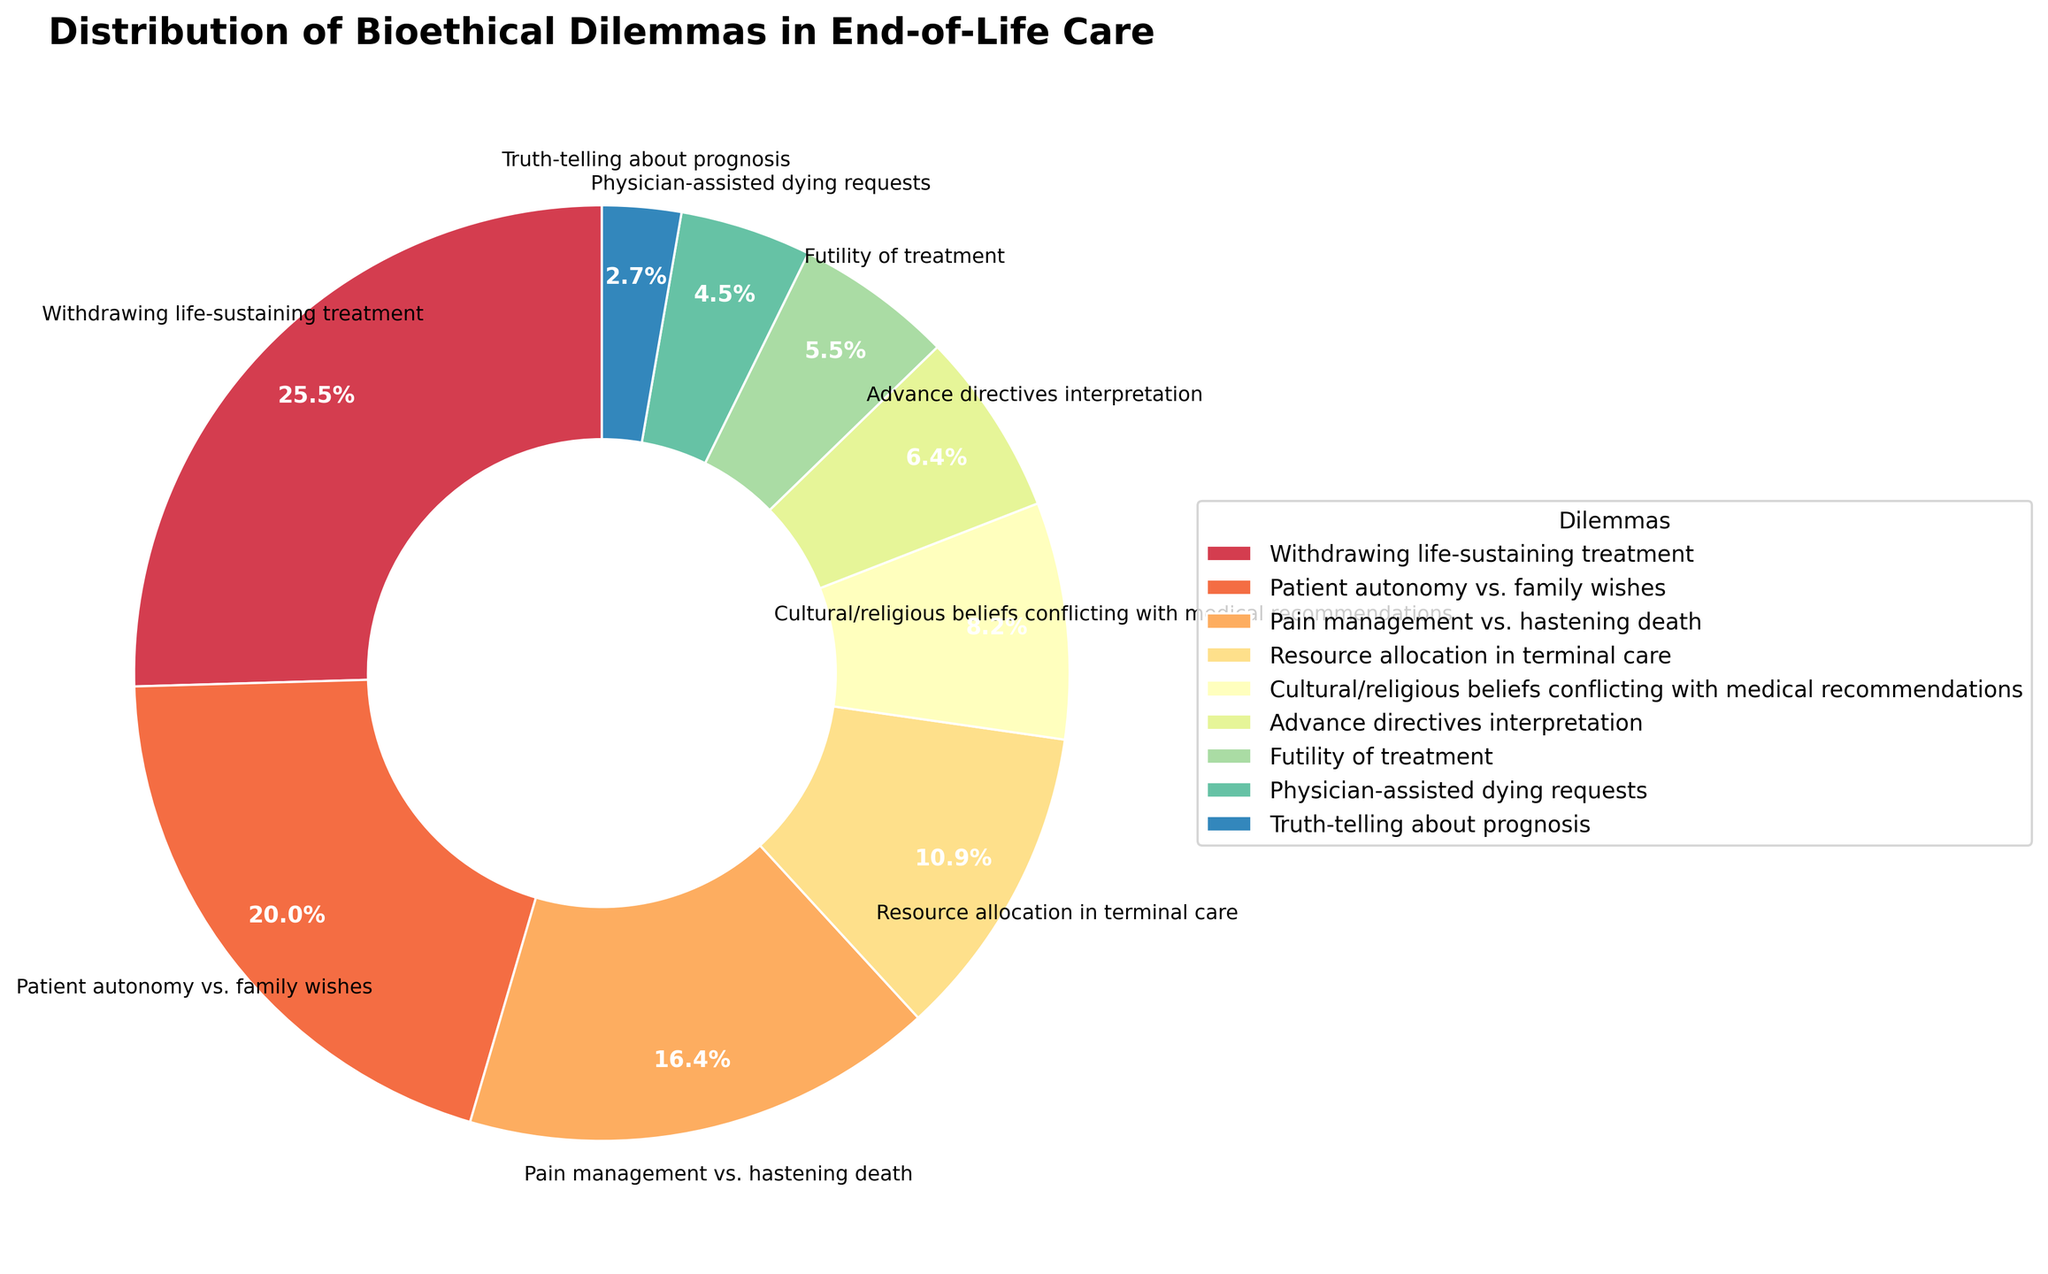What percentage of dilemmas are related to "Withdrawing life-sustaining treatment"? Look at the figure and find the wedge labeled "Withdrawing life-sustaining treatment." The percentage value is displayed within the wedge.
Answer: 28% Which ethical dilemma is represented by the smallest percentage? Examine the wedges in the pie chart and find the one with the smallest percentage value. The label associated with this wedge identifies the dilemma.
Answer: Truth-telling about prognosis What is the total percentage of dilemmas related to "Patient autonomy vs. family wishes" and "Pain management vs. hastening death"? Locate the wedges for "Patient autonomy vs. family wishes" and "Pain management vs. hastening death." Add their percentages, which are given in the figure.
Answer: 22 + 18 = 40% Which dilemma has a higher percentage: "Resource allocation in terminal care" or "Advance directives interpretation"? Compare the two respective wedges in the pie chart for "Resource allocation in terminal care" and "Advance directives interpretation" to determine which has a higher percentage.
Answer: Resource allocation in terminal care How does the percentage of "Cultural/religious beliefs conflicting with medical recommendations" compare to the percentage of "Physician-assisted dying requests"? Which is greater and by how much? Find the wedges for "Cultural/religious beliefs conflicting with medical recommendations" and "Physician-assisted dying requests." Subtract the smaller percentage from the larger to find the difference.
Answer: 9% - 5% = 4% What is the combined percentage of dilemmas related to "Futility of treatment" and "Truth-telling about prognosis"? Locate "Futility of treatment" and "Truth-telling about prognosis" in the chart. Add their percentages together.
Answer: 6% + 3% = 9% How many dilemmas have a percentage greater than 10%? Identify wedges where the percentage is greater than 10%. Count these wedges to provide the total number.
Answer: 4 In terms of percentage, what is the ratio of "Withdrawing life-sustaining treatment" to "Pain management vs. hastening death"? Find the percentages for both dilemmas in the chart. Use the ratio formula (percentage of first dilemma)/(percentage of second dilemma) to calculate.
Answer: 28/18 = 1.56 What is the difference in percentage between the dilemmas with the highest and lowest values? Identify the highest (Withdrawing life-sustaining treatment) and lowest (Truth-telling about prognosis) percentage values from the chart. Subtract the smallest from the largest.
Answer: 28% - 3% = 25% 